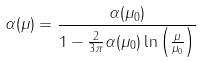Convert formula to latex. <formula><loc_0><loc_0><loc_500><loc_500>\alpha ( \mu ) = \frac { \alpha ( \mu _ { 0 } ) } { 1 - \frac { 2 } { 3 \pi } \alpha ( \mu _ { 0 } ) \ln \left ( \frac { \mu } { \mu _ { 0 } } \right ) }</formula> 